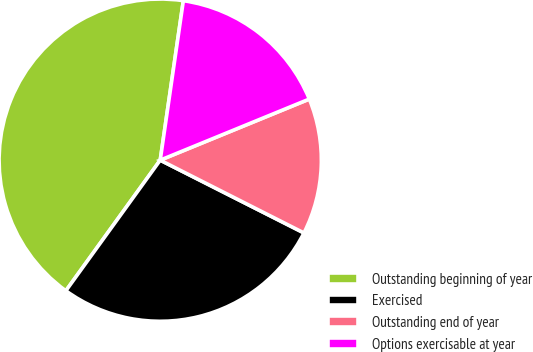Convert chart. <chart><loc_0><loc_0><loc_500><loc_500><pie_chart><fcel>Outstanding beginning of year<fcel>Exercised<fcel>Outstanding end of year<fcel>Options exercisable at year<nl><fcel>42.34%<fcel>27.5%<fcel>13.65%<fcel>16.52%<nl></chart> 